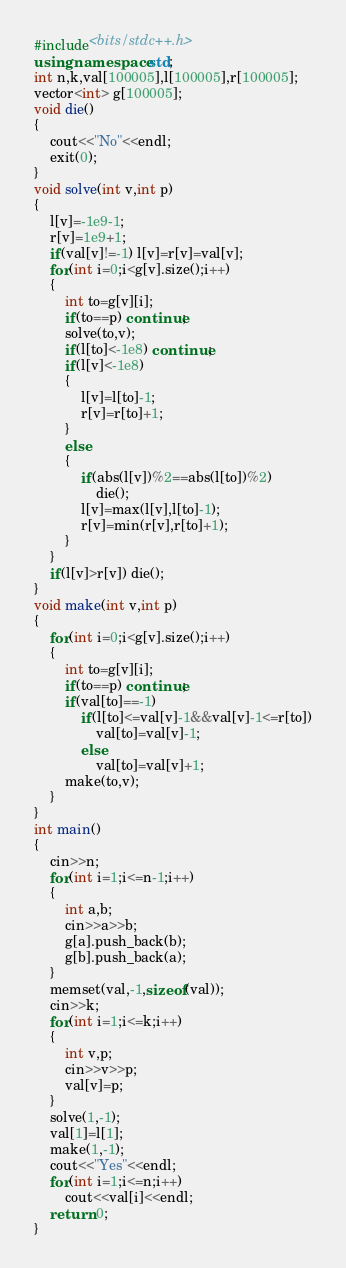Convert code to text. <code><loc_0><loc_0><loc_500><loc_500><_C++_>#include<bits/stdc++.h>
using namespace std;
int n,k,val[100005],l[100005],r[100005];
vector<int> g[100005];
void die()
{
	cout<<"No"<<endl;
	exit(0);
}
void solve(int v,int p)
{
	l[v]=-1e9-1;
	r[v]=1e9+1;
	if(val[v]!=-1) l[v]=r[v]=val[v];
	for(int i=0;i<g[v].size();i++)
	{
		int to=g[v][i];
		if(to==p) continue;
		solve(to,v);
		if(l[to]<-1e8) continue;
		if(l[v]<-1e8)
		{
			l[v]=l[to]-1;
			r[v]=r[to]+1;
		}
		else
		{
			if(abs(l[v])%2==abs(l[to])%2)
				die();
			l[v]=max(l[v],l[to]-1);
			r[v]=min(r[v],r[to]+1);
		}
	}
	if(l[v]>r[v]) die();
}
void make(int v,int p)
{
	for(int i=0;i<g[v].size();i++)
	{
		int to=g[v][i];
		if(to==p) continue;
		if(val[to]==-1)
			if(l[to]<=val[v]-1&&val[v]-1<=r[to])
				val[to]=val[v]-1;
			else
				val[to]=val[v]+1;
		make(to,v);
	}
}
int main()
{
	cin>>n;
	for(int i=1;i<=n-1;i++)
	{
		int a,b;
		cin>>a>>b;
		g[a].push_back(b);
		g[b].push_back(a);
	}
	memset(val,-1,sizeof(val));
	cin>>k;
	for(int i=1;i<=k;i++)
	{
		int v,p;
		cin>>v>>p;
		val[v]=p;
	}
	solve(1,-1);
	val[1]=l[1];
	make(1,-1);
	cout<<"Yes"<<endl;
	for(int i=1;i<=n;i++)
		cout<<val[i]<<endl;
	return 0;
}
</code> 